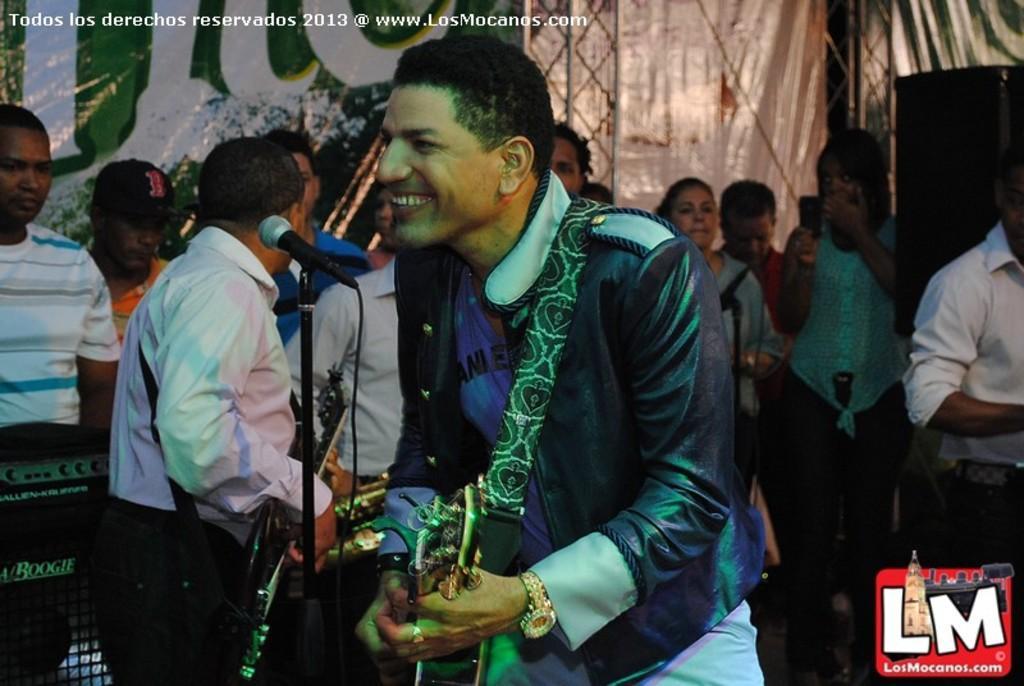Could you give a brief overview of what you see in this image? In this image I can see a person near the mike. In the background, I can see some people. I can also see some text written on the wall. 